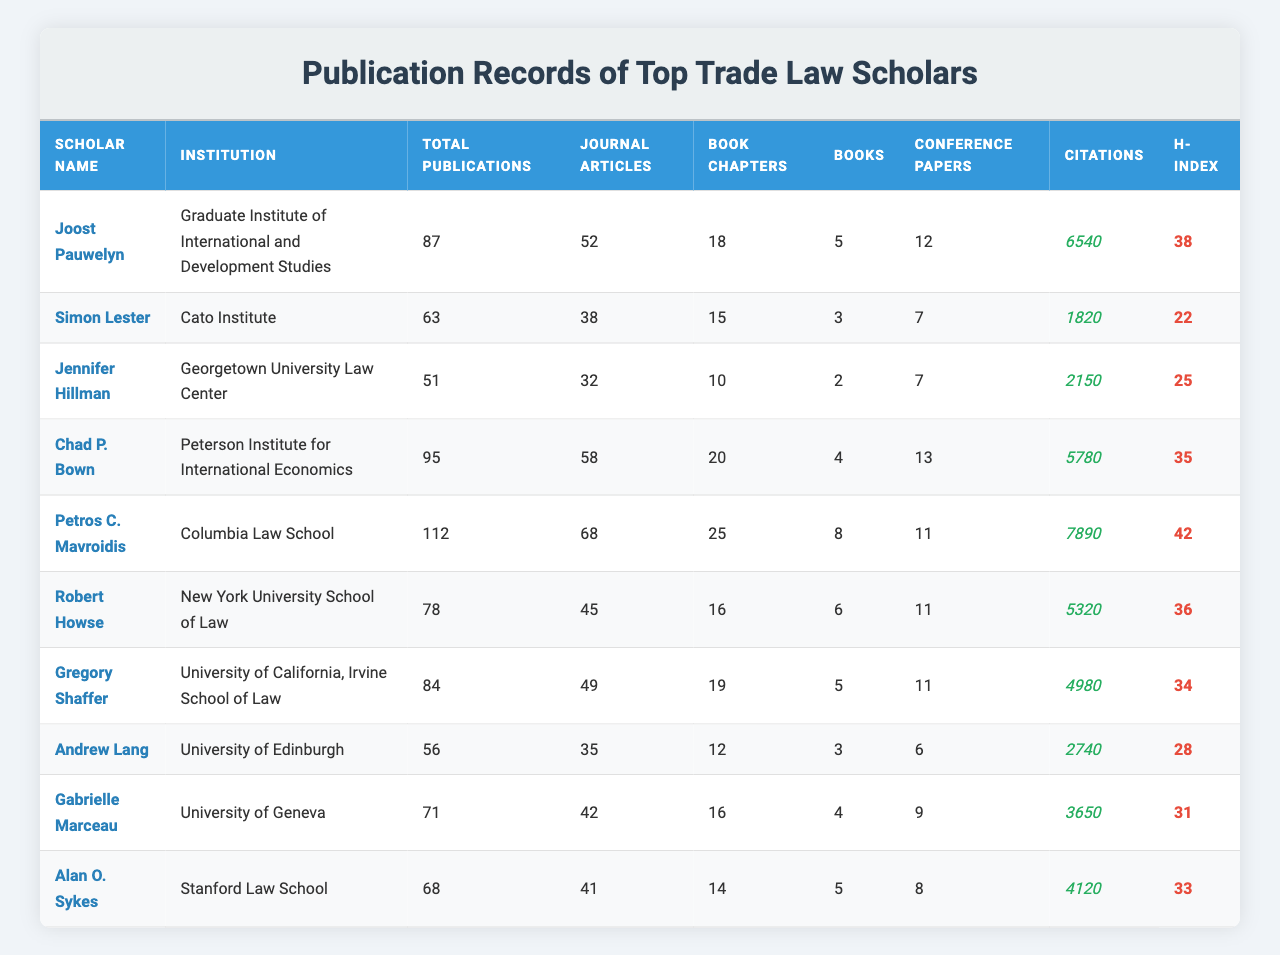What is the total number of publications by Petros C. Mavroidis? According to the table, Petros C. Mavroidis has a total of 112 publications listed.
Answer: 112 Who has the highest number of citations among the scholars? The table shows that Petros C. Mavroidis has the highest citations with a total of 7890.
Answer: 7890 How many journal articles has Simon Lester published? Simon Lester has published 38 journal articles, as indicated in the table.
Answer: 38 What is the H-index of Robert Howse, and what does it indicate? Robert Howse has an H-index of 36, which reflects a significant number of citations for his most-cited articles, indicating a strong impact in his field.
Answer: 36 Which scholar has the most books published, and how many? Petros C. Mavroidis has published the most books, totaling 8 according to the data.
Answer: 8 If we calculate the average number of journal articles published by the scholars listed, what is that average? Summing the journal articles (52 + 38 + 32 + 58 + 68 + 45 + 49 + 35 + 42 + 41) gives a total of 460. There are 10 scholars, so the average is 460/10 = 46.
Answer: 46 Is it true that Gabrielle Marceau has published more books than Andrew Lang? Gabrielle Marceau has published 4 books while Andrew Lang has published 3 books. Thus, the statement is true.
Answer: Yes What is the difference in total publications between Chad P. Bown and Joost Pauwelyn? Chad P. Bown has 95 total publications, and Joost Pauwelyn has 87. The difference is 95 - 87 = 8.
Answer: 8 Which scholar represents an institution associated with economics and has published at least 60 total publications? Chad P. Bown from the Peterson Institute for International Economics has 95 publications, fitting the criteria.
Answer: Chad P. Bown What is the median number of citations among the scholars listed? Arranging the citation numbers: 1820, 2150, 2740, 3650, 4120, 4980, 5320, 5780, 6540, 7890, the middle values (5th and 6th) are 4120 and 4980. The median is (4120 + 4980) / 2 = 4550.
Answer: 4550 